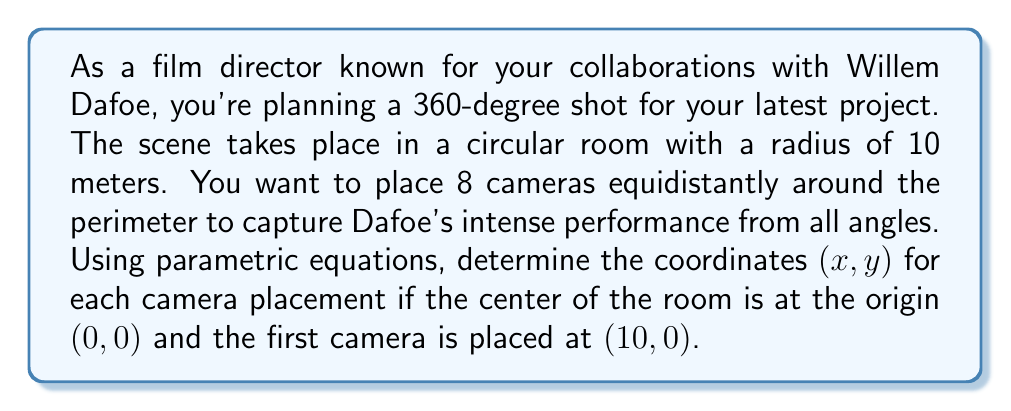Help me with this question. To solve this problem, we'll use parametric equations for a circle and divide the full rotation into 8 equal parts.

1) The parametric equations for a circle with radius $r$ are:
   $$x = r \cos(\theta)$$
   $$y = r \sin(\theta)$$

2) In this case, $r = 10$ meters.

3) For 8 cameras, we need to divide the full circle (2π radians) into 8 equal parts:
   $$\theta = \frac{2\pi}{8} = \frac{\pi}{4} \approx 0.7854 \text{ radians}$$

4) The angles for each camera will be multiples of $\frac{\pi}{4}$:
   Camera 1: $0$
   Camera 2: $\frac{\pi}{4}$
   Camera 3: $\frac{\pi}{2}$
   Camera 4: $\frac{3\pi}{4}$
   Camera 5: $\pi$
   Camera 6: $\frac{5\pi}{4}$
   Camera 7: $\frac{3\pi}{2}$
   Camera 8: $\frac{7\pi}{4}$

5) Now, we can calculate the coordinates for each camera:

   Camera 1: $(10 \cos(0), 10 \sin(0)) = (10, 0)$
   Camera 2: $(10 \cos(\frac{\pi}{4}), 10 \sin(\frac{\pi}{4})) \approx (7.07, 7.07)$
   Camera 3: $(10 \cos(\frac{\pi}{2}), 10 \sin(\frac{\pi}{2})) = (0, 10)$
   Camera 4: $(10 \cos(\frac{3\pi}{4}), 10 \sin(\frac{3\pi}{4})) \approx (-7.07, 7.07)$
   Camera 5: $(10 \cos(\pi), 10 \sin(\pi)) = (-10, 0)$
   Camera 6: $(10 \cos(\frac{5\pi}{4}), 10 \sin(\frac{5\pi}{4})) \approx (-7.07, -7.07)$
   Camera 7: $(10 \cos(\frac{3\pi}{2}), 10 \sin(\frac{3\pi}{2})) = (0, -10)$
   Camera 8: $(10 \cos(\frac{7\pi}{4}), 10 \sin(\frac{7\pi}{4})) \approx (7.07, -7.07)$

These coordinates ensure that the cameras are placed equidistantly around the circular room, allowing for a comprehensive 360-degree capture of Willem Dafoe's performance.
Answer: The coordinates $(x, y)$ for the 8 camera placements are:
1. $(10, 0)$
2. $(7.07, 7.07)$
3. $(0, 10)$
4. $(-7.07, 7.07)$
5. $(-10, 0)$
6. $(-7.07, -7.07)$
7. $(0, -10)$
8. $(7.07, -7.07)$ 